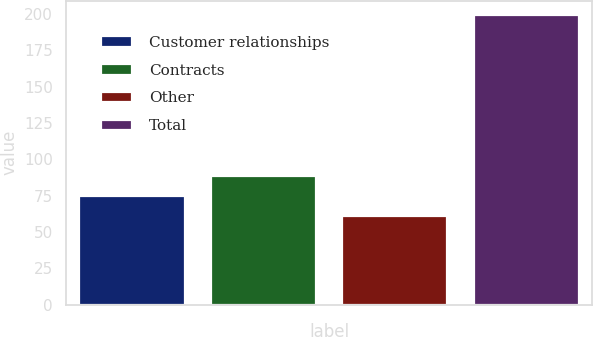Convert chart to OTSL. <chart><loc_0><loc_0><loc_500><loc_500><bar_chart><fcel>Customer relationships<fcel>Contracts<fcel>Other<fcel>Total<nl><fcel>74.8<fcel>88.6<fcel>61<fcel>199<nl></chart> 